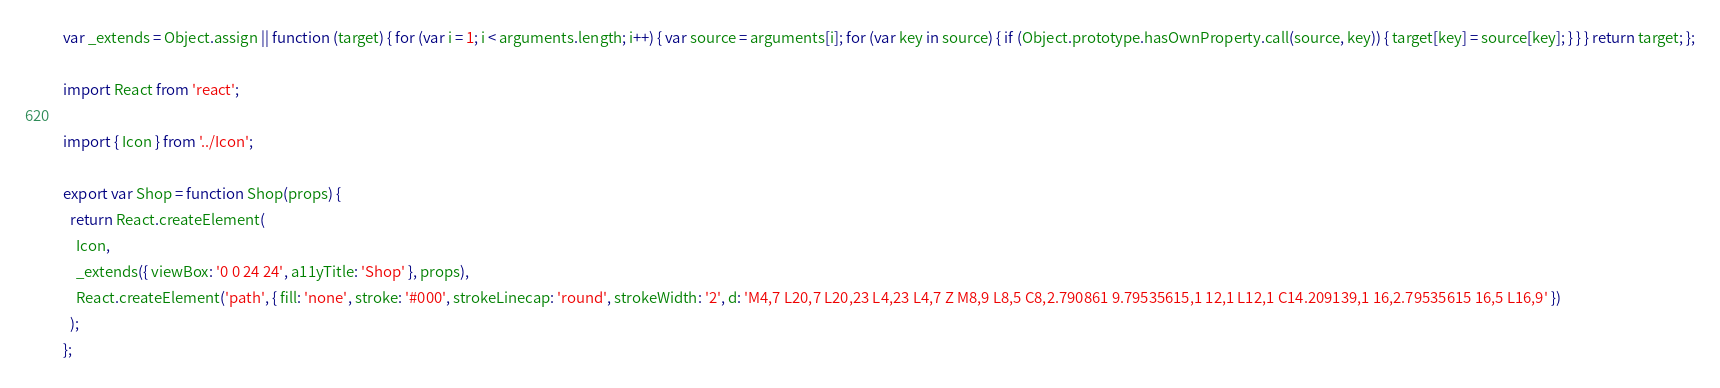Convert code to text. <code><loc_0><loc_0><loc_500><loc_500><_JavaScript_>var _extends = Object.assign || function (target) { for (var i = 1; i < arguments.length; i++) { var source = arguments[i]; for (var key in source) { if (Object.prototype.hasOwnProperty.call(source, key)) { target[key] = source[key]; } } } return target; };

import React from 'react';

import { Icon } from '../Icon';

export var Shop = function Shop(props) {
  return React.createElement(
    Icon,
    _extends({ viewBox: '0 0 24 24', a11yTitle: 'Shop' }, props),
    React.createElement('path', { fill: 'none', stroke: '#000', strokeLinecap: 'round', strokeWidth: '2', d: 'M4,7 L20,7 L20,23 L4,23 L4,7 Z M8,9 L8,5 C8,2.790861 9.79535615,1 12,1 L12,1 C14.209139,1 16,2.79535615 16,5 L16,9' })
  );
};</code> 